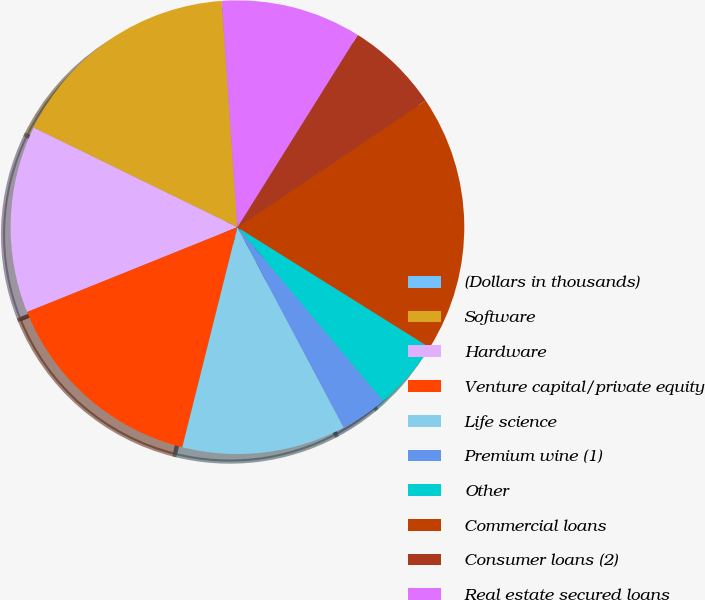<chart> <loc_0><loc_0><loc_500><loc_500><pie_chart><fcel>(Dollars in thousands)<fcel>Software<fcel>Hardware<fcel>Venture capital/private equity<fcel>Life science<fcel>Premium wine (1)<fcel>Other<fcel>Commercial loans<fcel>Consumer loans (2)<fcel>Real estate secured loans<nl><fcel>0.01%<fcel>16.66%<fcel>13.33%<fcel>15.0%<fcel>11.67%<fcel>3.34%<fcel>5.0%<fcel>18.33%<fcel>6.67%<fcel>10.0%<nl></chart> 